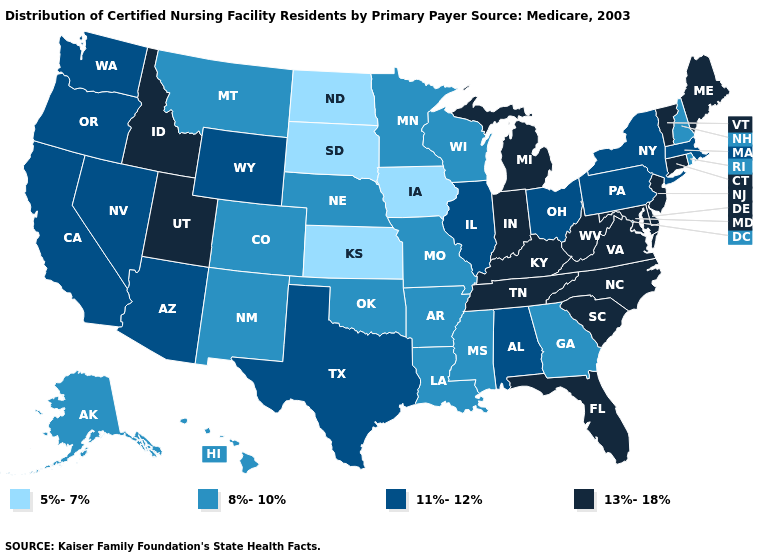What is the value of Iowa?
Concise answer only. 5%-7%. What is the lowest value in states that border Alabama?
Keep it brief. 8%-10%. Does North Dakota have the lowest value in the USA?
Give a very brief answer. Yes. Name the states that have a value in the range 5%-7%?
Answer briefly. Iowa, Kansas, North Dakota, South Dakota. Does the map have missing data?
Answer briefly. No. Name the states that have a value in the range 5%-7%?
Write a very short answer. Iowa, Kansas, North Dakota, South Dakota. Which states hav the highest value in the West?
Be succinct. Idaho, Utah. Is the legend a continuous bar?
Concise answer only. No. Does the first symbol in the legend represent the smallest category?
Answer briefly. Yes. Name the states that have a value in the range 5%-7%?
Write a very short answer. Iowa, Kansas, North Dakota, South Dakota. Among the states that border Arizona , which have the lowest value?
Answer briefly. Colorado, New Mexico. Does Alabama have the same value as California?
Be succinct. Yes. What is the value of Alaska?
Quick response, please. 8%-10%. What is the highest value in states that border Wisconsin?
Write a very short answer. 13%-18%. Name the states that have a value in the range 5%-7%?
Keep it brief. Iowa, Kansas, North Dakota, South Dakota. 